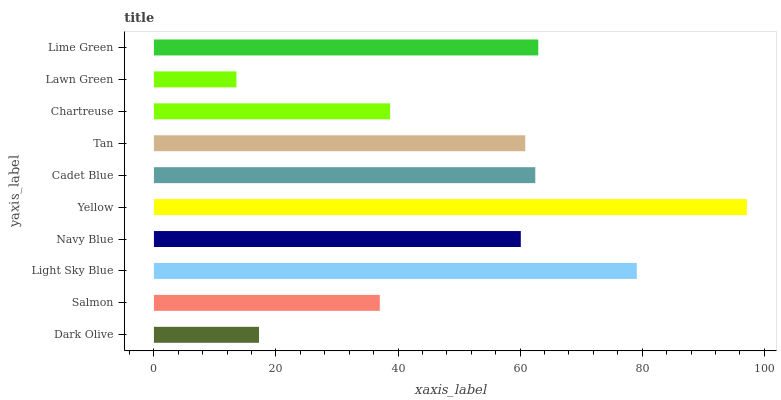Is Lawn Green the minimum?
Answer yes or no. Yes. Is Yellow the maximum?
Answer yes or no. Yes. Is Salmon the minimum?
Answer yes or no. No. Is Salmon the maximum?
Answer yes or no. No. Is Salmon greater than Dark Olive?
Answer yes or no. Yes. Is Dark Olive less than Salmon?
Answer yes or no. Yes. Is Dark Olive greater than Salmon?
Answer yes or no. No. Is Salmon less than Dark Olive?
Answer yes or no. No. Is Tan the high median?
Answer yes or no. Yes. Is Navy Blue the low median?
Answer yes or no. Yes. Is Chartreuse the high median?
Answer yes or no. No. Is Salmon the low median?
Answer yes or no. No. 